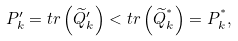Convert formula to latex. <formula><loc_0><loc_0><loc_500><loc_500>P _ { k } ^ { \prime } = t r \left ( \widetilde { Q } _ { k } ^ { \prime } \right ) < t r \left ( \widetilde { Q } _ { k } ^ { ^ { * } } \right ) = P _ { k } ^ { ^ { * } } ,</formula> 